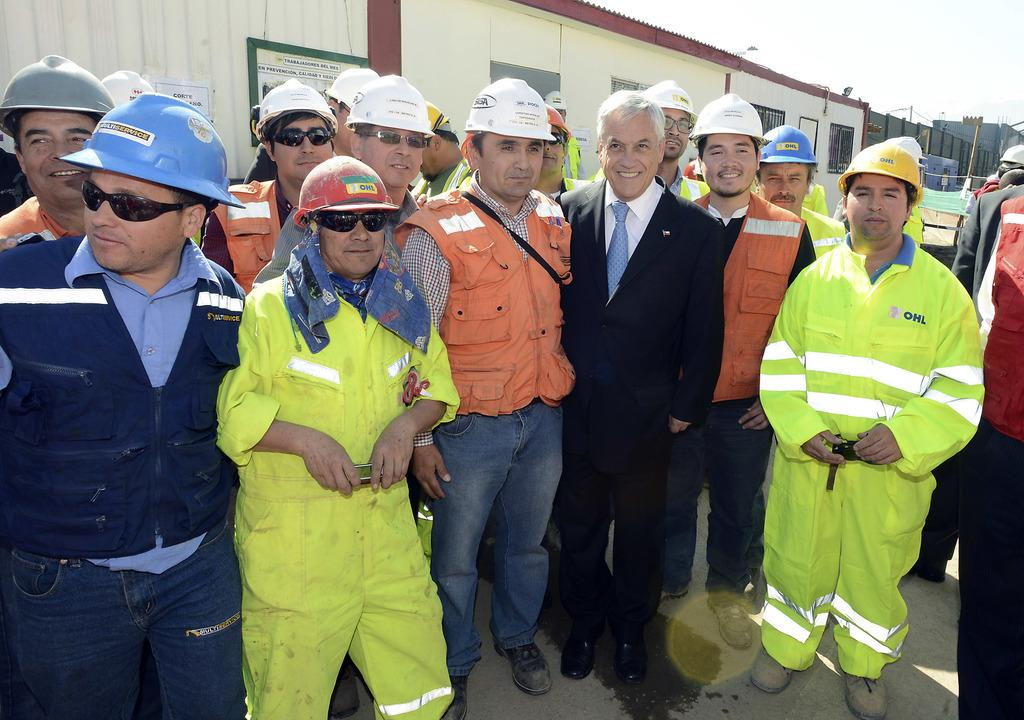How many people are in the image? There is a group of people in the image, but the exact number is not specified. What are the people wearing on their heads? The people are wearing helmets. What can be seen in the background of the image? There is a wall, windows, a pole, and the sky visible in the background of the image. What is the group of people protesting about in the image? There is no indication of a protest in the image; the people are simply wearing helmets. What does the group of people need in the image? The image does not provide any information about the group's needs or desires. 